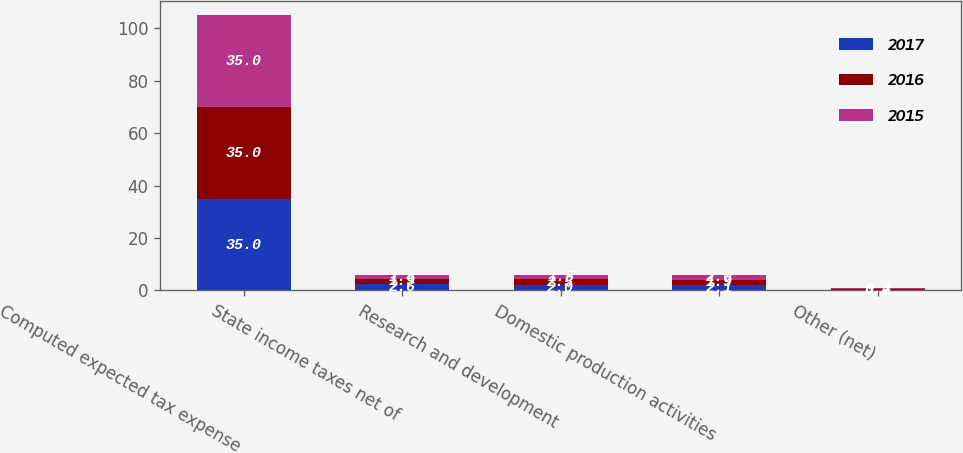Convert chart. <chart><loc_0><loc_0><loc_500><loc_500><stacked_bar_chart><ecel><fcel>Computed expected tax expense<fcel>State income taxes net of<fcel>Research and development<fcel>Domestic production activities<fcel>Other (net)<nl><fcel>2017<fcel>35<fcel>2.6<fcel>2<fcel>2.1<fcel>0.2<nl><fcel>2016<fcel>35<fcel>1.9<fcel>2.5<fcel>1.9<fcel>0.2<nl><fcel>2015<fcel>35<fcel>1.4<fcel>1.5<fcel>2<fcel>0.4<nl></chart> 